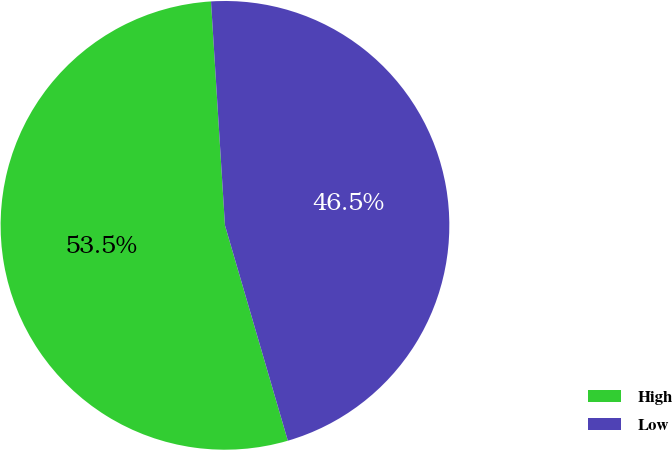Convert chart. <chart><loc_0><loc_0><loc_500><loc_500><pie_chart><fcel>High<fcel>Low<nl><fcel>53.53%<fcel>46.47%<nl></chart> 